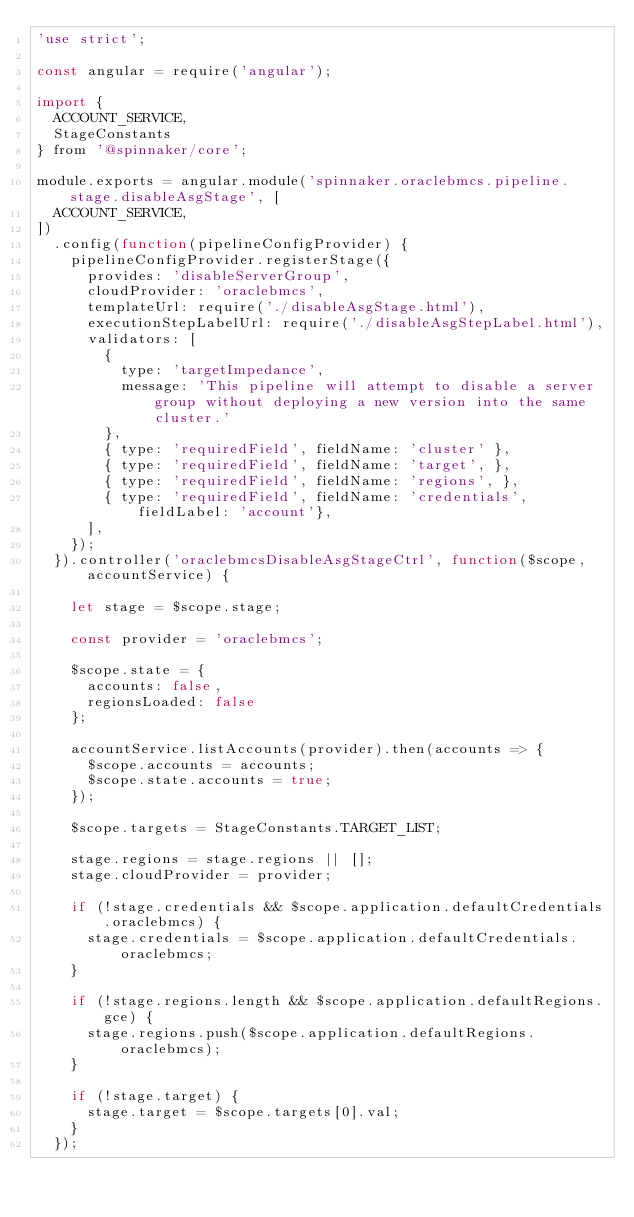<code> <loc_0><loc_0><loc_500><loc_500><_JavaScript_>'use strict';

const angular = require('angular');

import {
  ACCOUNT_SERVICE,
  StageConstants
} from '@spinnaker/core';

module.exports = angular.module('spinnaker.oraclebmcs.pipeline.stage.disableAsgStage', [
  ACCOUNT_SERVICE,
])
  .config(function(pipelineConfigProvider) {
    pipelineConfigProvider.registerStage({
      provides: 'disableServerGroup',
      cloudProvider: 'oraclebmcs',
      templateUrl: require('./disableAsgStage.html'),
      executionStepLabelUrl: require('./disableAsgStepLabel.html'),
      validators: [
        {
          type: 'targetImpedance',
          message: 'This pipeline will attempt to disable a server group without deploying a new version into the same cluster.'
        },
        { type: 'requiredField', fieldName: 'cluster' },
        { type: 'requiredField', fieldName: 'target', },
        { type: 'requiredField', fieldName: 'regions', },
        { type: 'requiredField', fieldName: 'credentials', fieldLabel: 'account'},
      ],
    });
  }).controller('oraclebmcsDisableAsgStageCtrl', function($scope, accountService) {

    let stage = $scope.stage;

    const provider = 'oraclebmcs';

    $scope.state = {
      accounts: false,
      regionsLoaded: false
    };

    accountService.listAccounts(provider).then(accounts => {
      $scope.accounts = accounts;
      $scope.state.accounts = true;
    });

    $scope.targets = StageConstants.TARGET_LIST;

    stage.regions = stage.regions || [];
    stage.cloudProvider = provider;

    if (!stage.credentials && $scope.application.defaultCredentials.oraclebmcs) {
      stage.credentials = $scope.application.defaultCredentials.oraclebmcs;
    }

    if (!stage.regions.length && $scope.application.defaultRegions.gce) {
      stage.regions.push($scope.application.defaultRegions.oraclebmcs);
    }

    if (!stage.target) {
      stage.target = $scope.targets[0].val;
    }
  });
</code> 